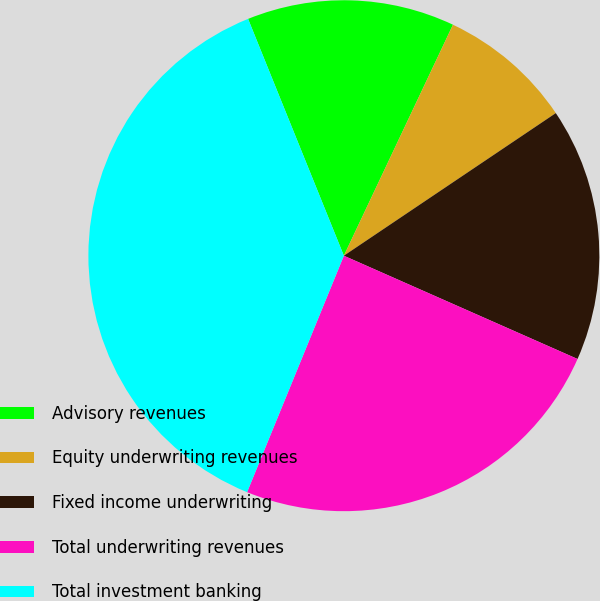Convert chart to OTSL. <chart><loc_0><loc_0><loc_500><loc_500><pie_chart><fcel>Advisory revenues<fcel>Equity underwriting revenues<fcel>Fixed income underwriting<fcel>Total underwriting revenues<fcel>Total investment banking<nl><fcel>13.14%<fcel>8.55%<fcel>16.05%<fcel>24.56%<fcel>37.7%<nl></chart> 